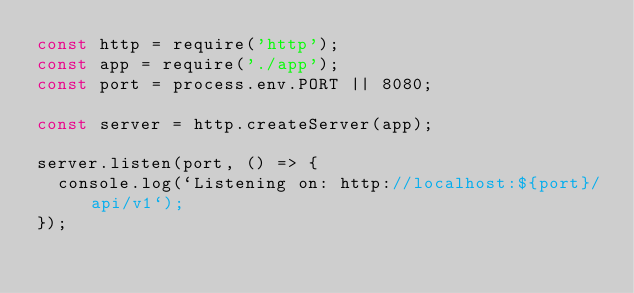<code> <loc_0><loc_0><loc_500><loc_500><_JavaScript_>const http = require('http');
const app = require('./app');
const port = process.env.PORT || 8080;

const server = http.createServer(app);

server.listen(port, () => {
  console.log(`Listening on: http://localhost:${port}/api/v1`);
});</code> 